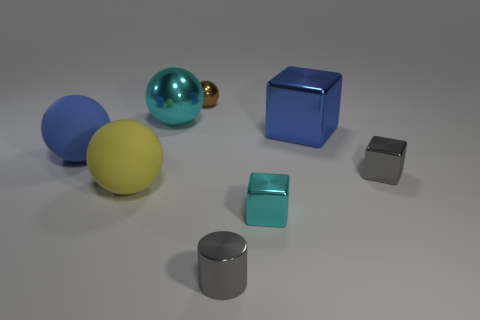Subtract all gray cubes. Subtract all purple balls. How many cubes are left? 2 Add 2 small objects. How many objects exist? 10 Subtract all blocks. How many objects are left? 5 Subtract 0 purple cubes. How many objects are left? 8 Subtract all small brown metallic objects. Subtract all blue matte things. How many objects are left? 6 Add 1 gray metal cylinders. How many gray metal cylinders are left? 2 Add 7 large blue matte balls. How many large blue matte balls exist? 8 